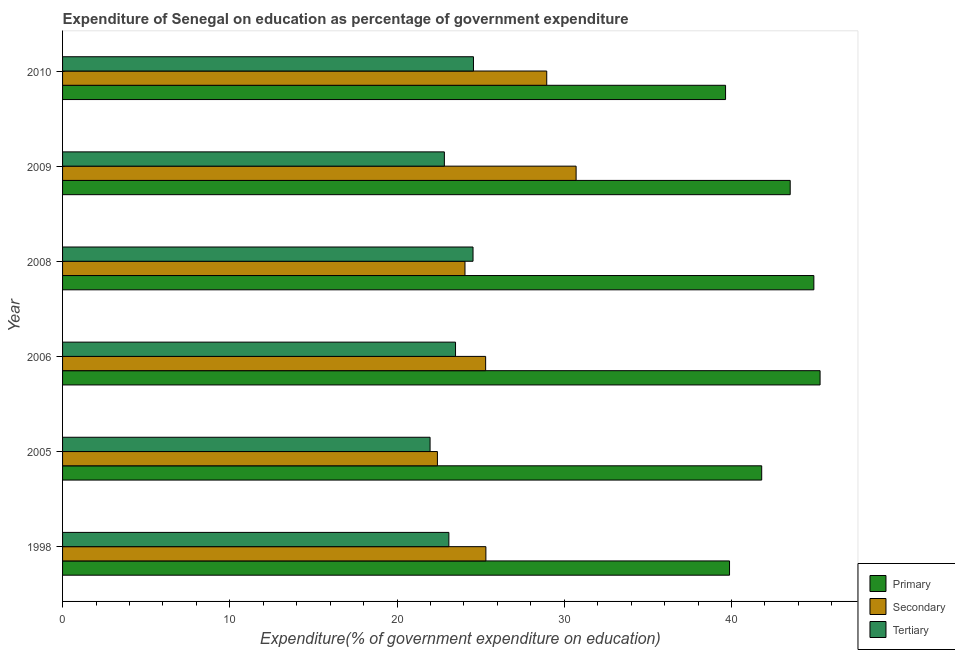How many different coloured bars are there?
Keep it short and to the point. 3. Are the number of bars per tick equal to the number of legend labels?
Your answer should be compact. Yes. How many bars are there on the 3rd tick from the bottom?
Ensure brevity in your answer.  3. What is the label of the 4th group of bars from the top?
Your response must be concise. 2006. What is the expenditure on tertiary education in 2006?
Provide a short and direct response. 23.5. Across all years, what is the maximum expenditure on tertiary education?
Offer a terse response. 24.57. Across all years, what is the minimum expenditure on primary education?
Offer a terse response. 39.65. What is the total expenditure on secondary education in the graph?
Offer a very short reply. 156.76. What is the difference between the expenditure on primary education in 2006 and that in 2008?
Offer a terse response. 0.37. What is the difference between the expenditure on tertiary education in 2009 and the expenditure on secondary education in 2010?
Keep it short and to the point. -6.12. What is the average expenditure on secondary education per year?
Your response must be concise. 26.13. In the year 2005, what is the difference between the expenditure on secondary education and expenditure on primary education?
Make the answer very short. -19.39. What is the ratio of the expenditure on secondary education in 2005 to that in 2009?
Offer a very short reply. 0.73. Is the expenditure on tertiary education in 2005 less than that in 2009?
Provide a short and direct response. Yes. What is the difference between the highest and the second highest expenditure on tertiary education?
Offer a very short reply. 0.03. What is the difference between the highest and the lowest expenditure on tertiary education?
Give a very brief answer. 2.59. What does the 2nd bar from the top in 2005 represents?
Offer a very short reply. Secondary. What does the 3rd bar from the bottom in 2010 represents?
Keep it short and to the point. Tertiary. Is it the case that in every year, the sum of the expenditure on primary education and expenditure on secondary education is greater than the expenditure on tertiary education?
Provide a succinct answer. Yes. Are all the bars in the graph horizontal?
Your answer should be compact. Yes. What is the difference between two consecutive major ticks on the X-axis?
Provide a succinct answer. 10. Does the graph contain any zero values?
Give a very brief answer. No. Does the graph contain grids?
Your answer should be very brief. No. How are the legend labels stacked?
Your answer should be very brief. Vertical. What is the title of the graph?
Your response must be concise. Expenditure of Senegal on education as percentage of government expenditure. What is the label or title of the X-axis?
Keep it short and to the point. Expenditure(% of government expenditure on education). What is the label or title of the Y-axis?
Give a very brief answer. Year. What is the Expenditure(% of government expenditure on education) of Primary in 1998?
Ensure brevity in your answer.  39.88. What is the Expenditure(% of government expenditure on education) of Secondary in 1998?
Ensure brevity in your answer.  25.32. What is the Expenditure(% of government expenditure on education) in Tertiary in 1998?
Your answer should be compact. 23.1. What is the Expenditure(% of government expenditure on education) in Primary in 2005?
Your response must be concise. 41.81. What is the Expenditure(% of government expenditure on education) of Secondary in 2005?
Give a very brief answer. 22.42. What is the Expenditure(% of government expenditure on education) in Tertiary in 2005?
Your response must be concise. 21.98. What is the Expenditure(% of government expenditure on education) in Primary in 2006?
Make the answer very short. 45.3. What is the Expenditure(% of government expenditure on education) of Secondary in 2006?
Keep it short and to the point. 25.3. What is the Expenditure(% of government expenditure on education) of Tertiary in 2006?
Give a very brief answer. 23.5. What is the Expenditure(% of government expenditure on education) in Primary in 2008?
Provide a short and direct response. 44.93. What is the Expenditure(% of government expenditure on education) in Secondary in 2008?
Ensure brevity in your answer.  24.06. What is the Expenditure(% of government expenditure on education) of Tertiary in 2008?
Give a very brief answer. 24.55. What is the Expenditure(% of government expenditure on education) in Primary in 2009?
Ensure brevity in your answer.  43.51. What is the Expenditure(% of government expenditure on education) of Secondary in 2009?
Offer a very short reply. 30.71. What is the Expenditure(% of government expenditure on education) of Tertiary in 2009?
Provide a short and direct response. 22.83. What is the Expenditure(% of government expenditure on education) in Primary in 2010?
Provide a succinct answer. 39.65. What is the Expenditure(% of government expenditure on education) of Secondary in 2010?
Make the answer very short. 28.95. What is the Expenditure(% of government expenditure on education) of Tertiary in 2010?
Ensure brevity in your answer.  24.57. Across all years, what is the maximum Expenditure(% of government expenditure on education) in Primary?
Your answer should be compact. 45.3. Across all years, what is the maximum Expenditure(% of government expenditure on education) in Secondary?
Make the answer very short. 30.71. Across all years, what is the maximum Expenditure(% of government expenditure on education) in Tertiary?
Your response must be concise. 24.57. Across all years, what is the minimum Expenditure(% of government expenditure on education) of Primary?
Make the answer very short. 39.65. Across all years, what is the minimum Expenditure(% of government expenditure on education) of Secondary?
Your response must be concise. 22.42. Across all years, what is the minimum Expenditure(% of government expenditure on education) in Tertiary?
Make the answer very short. 21.98. What is the total Expenditure(% of government expenditure on education) of Primary in the graph?
Make the answer very short. 255.08. What is the total Expenditure(% of government expenditure on education) of Secondary in the graph?
Ensure brevity in your answer.  156.76. What is the total Expenditure(% of government expenditure on education) of Tertiary in the graph?
Offer a very short reply. 140.53. What is the difference between the Expenditure(% of government expenditure on education) in Primary in 1998 and that in 2005?
Ensure brevity in your answer.  -1.92. What is the difference between the Expenditure(% of government expenditure on education) in Secondary in 1998 and that in 2005?
Provide a succinct answer. 2.9. What is the difference between the Expenditure(% of government expenditure on education) of Tertiary in 1998 and that in 2005?
Provide a short and direct response. 1.12. What is the difference between the Expenditure(% of government expenditure on education) of Primary in 1998 and that in 2006?
Give a very brief answer. -5.42. What is the difference between the Expenditure(% of government expenditure on education) of Secondary in 1998 and that in 2006?
Ensure brevity in your answer.  0.02. What is the difference between the Expenditure(% of government expenditure on education) of Tertiary in 1998 and that in 2006?
Your answer should be very brief. -0.4. What is the difference between the Expenditure(% of government expenditure on education) in Primary in 1998 and that in 2008?
Make the answer very short. -5.04. What is the difference between the Expenditure(% of government expenditure on education) in Secondary in 1998 and that in 2008?
Offer a terse response. 1.25. What is the difference between the Expenditure(% of government expenditure on education) in Tertiary in 1998 and that in 2008?
Give a very brief answer. -1.45. What is the difference between the Expenditure(% of government expenditure on education) of Primary in 1998 and that in 2009?
Offer a very short reply. -3.63. What is the difference between the Expenditure(% of government expenditure on education) in Secondary in 1998 and that in 2009?
Give a very brief answer. -5.4. What is the difference between the Expenditure(% of government expenditure on education) of Tertiary in 1998 and that in 2009?
Offer a terse response. 0.27. What is the difference between the Expenditure(% of government expenditure on education) of Primary in 1998 and that in 2010?
Ensure brevity in your answer.  0.24. What is the difference between the Expenditure(% of government expenditure on education) in Secondary in 1998 and that in 2010?
Provide a succinct answer. -3.64. What is the difference between the Expenditure(% of government expenditure on education) of Tertiary in 1998 and that in 2010?
Offer a terse response. -1.47. What is the difference between the Expenditure(% of government expenditure on education) in Primary in 2005 and that in 2006?
Offer a terse response. -3.49. What is the difference between the Expenditure(% of government expenditure on education) in Secondary in 2005 and that in 2006?
Your answer should be very brief. -2.88. What is the difference between the Expenditure(% of government expenditure on education) of Tertiary in 2005 and that in 2006?
Your answer should be compact. -1.52. What is the difference between the Expenditure(% of government expenditure on education) in Primary in 2005 and that in 2008?
Your answer should be compact. -3.12. What is the difference between the Expenditure(% of government expenditure on education) in Secondary in 2005 and that in 2008?
Offer a terse response. -1.65. What is the difference between the Expenditure(% of government expenditure on education) in Tertiary in 2005 and that in 2008?
Your response must be concise. -2.57. What is the difference between the Expenditure(% of government expenditure on education) in Primary in 2005 and that in 2009?
Your response must be concise. -1.7. What is the difference between the Expenditure(% of government expenditure on education) in Secondary in 2005 and that in 2009?
Offer a very short reply. -8.29. What is the difference between the Expenditure(% of government expenditure on education) of Tertiary in 2005 and that in 2009?
Provide a short and direct response. -0.85. What is the difference between the Expenditure(% of government expenditure on education) in Primary in 2005 and that in 2010?
Provide a succinct answer. 2.16. What is the difference between the Expenditure(% of government expenditure on education) of Secondary in 2005 and that in 2010?
Provide a succinct answer. -6.54. What is the difference between the Expenditure(% of government expenditure on education) of Tertiary in 2005 and that in 2010?
Keep it short and to the point. -2.59. What is the difference between the Expenditure(% of government expenditure on education) in Primary in 2006 and that in 2008?
Provide a short and direct response. 0.37. What is the difference between the Expenditure(% of government expenditure on education) of Secondary in 2006 and that in 2008?
Provide a short and direct response. 1.24. What is the difference between the Expenditure(% of government expenditure on education) of Tertiary in 2006 and that in 2008?
Give a very brief answer. -1.05. What is the difference between the Expenditure(% of government expenditure on education) of Primary in 2006 and that in 2009?
Your answer should be very brief. 1.79. What is the difference between the Expenditure(% of government expenditure on education) of Secondary in 2006 and that in 2009?
Your answer should be compact. -5.41. What is the difference between the Expenditure(% of government expenditure on education) in Tertiary in 2006 and that in 2009?
Keep it short and to the point. 0.67. What is the difference between the Expenditure(% of government expenditure on education) in Primary in 2006 and that in 2010?
Ensure brevity in your answer.  5.65. What is the difference between the Expenditure(% of government expenditure on education) of Secondary in 2006 and that in 2010?
Offer a very short reply. -3.65. What is the difference between the Expenditure(% of government expenditure on education) of Tertiary in 2006 and that in 2010?
Make the answer very short. -1.07. What is the difference between the Expenditure(% of government expenditure on education) in Primary in 2008 and that in 2009?
Make the answer very short. 1.41. What is the difference between the Expenditure(% of government expenditure on education) in Secondary in 2008 and that in 2009?
Provide a short and direct response. -6.65. What is the difference between the Expenditure(% of government expenditure on education) of Tertiary in 2008 and that in 2009?
Provide a succinct answer. 1.71. What is the difference between the Expenditure(% of government expenditure on education) in Primary in 2008 and that in 2010?
Ensure brevity in your answer.  5.28. What is the difference between the Expenditure(% of government expenditure on education) in Secondary in 2008 and that in 2010?
Offer a very short reply. -4.89. What is the difference between the Expenditure(% of government expenditure on education) in Tertiary in 2008 and that in 2010?
Offer a very short reply. -0.03. What is the difference between the Expenditure(% of government expenditure on education) of Primary in 2009 and that in 2010?
Provide a succinct answer. 3.87. What is the difference between the Expenditure(% of government expenditure on education) in Secondary in 2009 and that in 2010?
Your answer should be compact. 1.76. What is the difference between the Expenditure(% of government expenditure on education) in Tertiary in 2009 and that in 2010?
Provide a short and direct response. -1.74. What is the difference between the Expenditure(% of government expenditure on education) in Primary in 1998 and the Expenditure(% of government expenditure on education) in Secondary in 2005?
Keep it short and to the point. 17.47. What is the difference between the Expenditure(% of government expenditure on education) in Primary in 1998 and the Expenditure(% of government expenditure on education) in Tertiary in 2005?
Ensure brevity in your answer.  17.91. What is the difference between the Expenditure(% of government expenditure on education) in Secondary in 1998 and the Expenditure(% of government expenditure on education) in Tertiary in 2005?
Keep it short and to the point. 3.34. What is the difference between the Expenditure(% of government expenditure on education) of Primary in 1998 and the Expenditure(% of government expenditure on education) of Secondary in 2006?
Offer a very short reply. 14.58. What is the difference between the Expenditure(% of government expenditure on education) of Primary in 1998 and the Expenditure(% of government expenditure on education) of Tertiary in 2006?
Your answer should be compact. 16.38. What is the difference between the Expenditure(% of government expenditure on education) of Secondary in 1998 and the Expenditure(% of government expenditure on education) of Tertiary in 2006?
Ensure brevity in your answer.  1.82. What is the difference between the Expenditure(% of government expenditure on education) in Primary in 1998 and the Expenditure(% of government expenditure on education) in Secondary in 2008?
Your response must be concise. 15.82. What is the difference between the Expenditure(% of government expenditure on education) of Primary in 1998 and the Expenditure(% of government expenditure on education) of Tertiary in 2008?
Give a very brief answer. 15.34. What is the difference between the Expenditure(% of government expenditure on education) in Secondary in 1998 and the Expenditure(% of government expenditure on education) in Tertiary in 2008?
Give a very brief answer. 0.77. What is the difference between the Expenditure(% of government expenditure on education) in Primary in 1998 and the Expenditure(% of government expenditure on education) in Secondary in 2009?
Offer a very short reply. 9.17. What is the difference between the Expenditure(% of government expenditure on education) in Primary in 1998 and the Expenditure(% of government expenditure on education) in Tertiary in 2009?
Your answer should be compact. 17.05. What is the difference between the Expenditure(% of government expenditure on education) of Secondary in 1998 and the Expenditure(% of government expenditure on education) of Tertiary in 2009?
Ensure brevity in your answer.  2.48. What is the difference between the Expenditure(% of government expenditure on education) of Primary in 1998 and the Expenditure(% of government expenditure on education) of Secondary in 2010?
Provide a succinct answer. 10.93. What is the difference between the Expenditure(% of government expenditure on education) in Primary in 1998 and the Expenditure(% of government expenditure on education) in Tertiary in 2010?
Give a very brief answer. 15.31. What is the difference between the Expenditure(% of government expenditure on education) in Secondary in 1998 and the Expenditure(% of government expenditure on education) in Tertiary in 2010?
Give a very brief answer. 0.74. What is the difference between the Expenditure(% of government expenditure on education) in Primary in 2005 and the Expenditure(% of government expenditure on education) in Secondary in 2006?
Give a very brief answer. 16.51. What is the difference between the Expenditure(% of government expenditure on education) in Primary in 2005 and the Expenditure(% of government expenditure on education) in Tertiary in 2006?
Ensure brevity in your answer.  18.31. What is the difference between the Expenditure(% of government expenditure on education) of Secondary in 2005 and the Expenditure(% of government expenditure on education) of Tertiary in 2006?
Offer a terse response. -1.08. What is the difference between the Expenditure(% of government expenditure on education) in Primary in 2005 and the Expenditure(% of government expenditure on education) in Secondary in 2008?
Your response must be concise. 17.74. What is the difference between the Expenditure(% of government expenditure on education) in Primary in 2005 and the Expenditure(% of government expenditure on education) in Tertiary in 2008?
Ensure brevity in your answer.  17.26. What is the difference between the Expenditure(% of government expenditure on education) of Secondary in 2005 and the Expenditure(% of government expenditure on education) of Tertiary in 2008?
Offer a terse response. -2.13. What is the difference between the Expenditure(% of government expenditure on education) in Primary in 2005 and the Expenditure(% of government expenditure on education) in Secondary in 2009?
Your answer should be very brief. 11.1. What is the difference between the Expenditure(% of government expenditure on education) in Primary in 2005 and the Expenditure(% of government expenditure on education) in Tertiary in 2009?
Provide a short and direct response. 18.98. What is the difference between the Expenditure(% of government expenditure on education) in Secondary in 2005 and the Expenditure(% of government expenditure on education) in Tertiary in 2009?
Your answer should be very brief. -0.42. What is the difference between the Expenditure(% of government expenditure on education) of Primary in 2005 and the Expenditure(% of government expenditure on education) of Secondary in 2010?
Your answer should be very brief. 12.86. What is the difference between the Expenditure(% of government expenditure on education) of Primary in 2005 and the Expenditure(% of government expenditure on education) of Tertiary in 2010?
Provide a succinct answer. 17.24. What is the difference between the Expenditure(% of government expenditure on education) in Secondary in 2005 and the Expenditure(% of government expenditure on education) in Tertiary in 2010?
Provide a succinct answer. -2.16. What is the difference between the Expenditure(% of government expenditure on education) in Primary in 2006 and the Expenditure(% of government expenditure on education) in Secondary in 2008?
Your response must be concise. 21.24. What is the difference between the Expenditure(% of government expenditure on education) in Primary in 2006 and the Expenditure(% of government expenditure on education) in Tertiary in 2008?
Keep it short and to the point. 20.75. What is the difference between the Expenditure(% of government expenditure on education) in Secondary in 2006 and the Expenditure(% of government expenditure on education) in Tertiary in 2008?
Your answer should be very brief. 0.75. What is the difference between the Expenditure(% of government expenditure on education) of Primary in 2006 and the Expenditure(% of government expenditure on education) of Secondary in 2009?
Ensure brevity in your answer.  14.59. What is the difference between the Expenditure(% of government expenditure on education) of Primary in 2006 and the Expenditure(% of government expenditure on education) of Tertiary in 2009?
Provide a short and direct response. 22.47. What is the difference between the Expenditure(% of government expenditure on education) in Secondary in 2006 and the Expenditure(% of government expenditure on education) in Tertiary in 2009?
Make the answer very short. 2.47. What is the difference between the Expenditure(% of government expenditure on education) of Primary in 2006 and the Expenditure(% of government expenditure on education) of Secondary in 2010?
Your answer should be very brief. 16.35. What is the difference between the Expenditure(% of government expenditure on education) in Primary in 2006 and the Expenditure(% of government expenditure on education) in Tertiary in 2010?
Your answer should be very brief. 20.73. What is the difference between the Expenditure(% of government expenditure on education) in Secondary in 2006 and the Expenditure(% of government expenditure on education) in Tertiary in 2010?
Offer a very short reply. 0.73. What is the difference between the Expenditure(% of government expenditure on education) in Primary in 2008 and the Expenditure(% of government expenditure on education) in Secondary in 2009?
Ensure brevity in your answer.  14.22. What is the difference between the Expenditure(% of government expenditure on education) in Primary in 2008 and the Expenditure(% of government expenditure on education) in Tertiary in 2009?
Provide a succinct answer. 22.1. What is the difference between the Expenditure(% of government expenditure on education) in Secondary in 2008 and the Expenditure(% of government expenditure on education) in Tertiary in 2009?
Offer a terse response. 1.23. What is the difference between the Expenditure(% of government expenditure on education) of Primary in 2008 and the Expenditure(% of government expenditure on education) of Secondary in 2010?
Provide a short and direct response. 15.97. What is the difference between the Expenditure(% of government expenditure on education) of Primary in 2008 and the Expenditure(% of government expenditure on education) of Tertiary in 2010?
Your answer should be very brief. 20.36. What is the difference between the Expenditure(% of government expenditure on education) of Secondary in 2008 and the Expenditure(% of government expenditure on education) of Tertiary in 2010?
Your response must be concise. -0.51. What is the difference between the Expenditure(% of government expenditure on education) in Primary in 2009 and the Expenditure(% of government expenditure on education) in Secondary in 2010?
Offer a terse response. 14.56. What is the difference between the Expenditure(% of government expenditure on education) in Primary in 2009 and the Expenditure(% of government expenditure on education) in Tertiary in 2010?
Your answer should be compact. 18.94. What is the difference between the Expenditure(% of government expenditure on education) in Secondary in 2009 and the Expenditure(% of government expenditure on education) in Tertiary in 2010?
Make the answer very short. 6.14. What is the average Expenditure(% of government expenditure on education) in Primary per year?
Make the answer very short. 42.51. What is the average Expenditure(% of government expenditure on education) in Secondary per year?
Your answer should be compact. 26.13. What is the average Expenditure(% of government expenditure on education) in Tertiary per year?
Ensure brevity in your answer.  23.42. In the year 1998, what is the difference between the Expenditure(% of government expenditure on education) of Primary and Expenditure(% of government expenditure on education) of Secondary?
Keep it short and to the point. 14.57. In the year 1998, what is the difference between the Expenditure(% of government expenditure on education) in Primary and Expenditure(% of government expenditure on education) in Tertiary?
Provide a short and direct response. 16.78. In the year 1998, what is the difference between the Expenditure(% of government expenditure on education) of Secondary and Expenditure(% of government expenditure on education) of Tertiary?
Make the answer very short. 2.21. In the year 2005, what is the difference between the Expenditure(% of government expenditure on education) of Primary and Expenditure(% of government expenditure on education) of Secondary?
Provide a short and direct response. 19.39. In the year 2005, what is the difference between the Expenditure(% of government expenditure on education) of Primary and Expenditure(% of government expenditure on education) of Tertiary?
Provide a succinct answer. 19.83. In the year 2005, what is the difference between the Expenditure(% of government expenditure on education) in Secondary and Expenditure(% of government expenditure on education) in Tertiary?
Keep it short and to the point. 0.44. In the year 2006, what is the difference between the Expenditure(% of government expenditure on education) in Primary and Expenditure(% of government expenditure on education) in Secondary?
Offer a very short reply. 20. In the year 2006, what is the difference between the Expenditure(% of government expenditure on education) of Primary and Expenditure(% of government expenditure on education) of Tertiary?
Provide a short and direct response. 21.8. In the year 2006, what is the difference between the Expenditure(% of government expenditure on education) in Secondary and Expenditure(% of government expenditure on education) in Tertiary?
Keep it short and to the point. 1.8. In the year 2008, what is the difference between the Expenditure(% of government expenditure on education) in Primary and Expenditure(% of government expenditure on education) in Secondary?
Ensure brevity in your answer.  20.86. In the year 2008, what is the difference between the Expenditure(% of government expenditure on education) of Primary and Expenditure(% of government expenditure on education) of Tertiary?
Your answer should be compact. 20.38. In the year 2008, what is the difference between the Expenditure(% of government expenditure on education) of Secondary and Expenditure(% of government expenditure on education) of Tertiary?
Your answer should be very brief. -0.48. In the year 2009, what is the difference between the Expenditure(% of government expenditure on education) of Primary and Expenditure(% of government expenditure on education) of Secondary?
Ensure brevity in your answer.  12.8. In the year 2009, what is the difference between the Expenditure(% of government expenditure on education) of Primary and Expenditure(% of government expenditure on education) of Tertiary?
Your response must be concise. 20.68. In the year 2009, what is the difference between the Expenditure(% of government expenditure on education) of Secondary and Expenditure(% of government expenditure on education) of Tertiary?
Offer a terse response. 7.88. In the year 2010, what is the difference between the Expenditure(% of government expenditure on education) of Primary and Expenditure(% of government expenditure on education) of Secondary?
Ensure brevity in your answer.  10.69. In the year 2010, what is the difference between the Expenditure(% of government expenditure on education) in Primary and Expenditure(% of government expenditure on education) in Tertiary?
Give a very brief answer. 15.08. In the year 2010, what is the difference between the Expenditure(% of government expenditure on education) of Secondary and Expenditure(% of government expenditure on education) of Tertiary?
Provide a succinct answer. 4.38. What is the ratio of the Expenditure(% of government expenditure on education) in Primary in 1998 to that in 2005?
Give a very brief answer. 0.95. What is the ratio of the Expenditure(% of government expenditure on education) of Secondary in 1998 to that in 2005?
Make the answer very short. 1.13. What is the ratio of the Expenditure(% of government expenditure on education) of Tertiary in 1998 to that in 2005?
Your answer should be very brief. 1.05. What is the ratio of the Expenditure(% of government expenditure on education) in Primary in 1998 to that in 2006?
Provide a succinct answer. 0.88. What is the ratio of the Expenditure(% of government expenditure on education) of Secondary in 1998 to that in 2006?
Make the answer very short. 1. What is the ratio of the Expenditure(% of government expenditure on education) in Primary in 1998 to that in 2008?
Your response must be concise. 0.89. What is the ratio of the Expenditure(% of government expenditure on education) of Secondary in 1998 to that in 2008?
Make the answer very short. 1.05. What is the ratio of the Expenditure(% of government expenditure on education) in Tertiary in 1998 to that in 2008?
Provide a succinct answer. 0.94. What is the ratio of the Expenditure(% of government expenditure on education) of Primary in 1998 to that in 2009?
Offer a terse response. 0.92. What is the ratio of the Expenditure(% of government expenditure on education) of Secondary in 1998 to that in 2009?
Offer a terse response. 0.82. What is the ratio of the Expenditure(% of government expenditure on education) in Tertiary in 1998 to that in 2009?
Make the answer very short. 1.01. What is the ratio of the Expenditure(% of government expenditure on education) of Primary in 1998 to that in 2010?
Your answer should be compact. 1.01. What is the ratio of the Expenditure(% of government expenditure on education) in Secondary in 1998 to that in 2010?
Your answer should be compact. 0.87. What is the ratio of the Expenditure(% of government expenditure on education) in Tertiary in 1998 to that in 2010?
Make the answer very short. 0.94. What is the ratio of the Expenditure(% of government expenditure on education) in Primary in 2005 to that in 2006?
Your response must be concise. 0.92. What is the ratio of the Expenditure(% of government expenditure on education) of Secondary in 2005 to that in 2006?
Ensure brevity in your answer.  0.89. What is the ratio of the Expenditure(% of government expenditure on education) of Tertiary in 2005 to that in 2006?
Give a very brief answer. 0.94. What is the ratio of the Expenditure(% of government expenditure on education) of Primary in 2005 to that in 2008?
Make the answer very short. 0.93. What is the ratio of the Expenditure(% of government expenditure on education) in Secondary in 2005 to that in 2008?
Give a very brief answer. 0.93. What is the ratio of the Expenditure(% of government expenditure on education) in Tertiary in 2005 to that in 2008?
Keep it short and to the point. 0.9. What is the ratio of the Expenditure(% of government expenditure on education) of Primary in 2005 to that in 2009?
Your answer should be very brief. 0.96. What is the ratio of the Expenditure(% of government expenditure on education) of Secondary in 2005 to that in 2009?
Offer a terse response. 0.73. What is the ratio of the Expenditure(% of government expenditure on education) in Tertiary in 2005 to that in 2009?
Provide a short and direct response. 0.96. What is the ratio of the Expenditure(% of government expenditure on education) of Primary in 2005 to that in 2010?
Keep it short and to the point. 1.05. What is the ratio of the Expenditure(% of government expenditure on education) of Secondary in 2005 to that in 2010?
Keep it short and to the point. 0.77. What is the ratio of the Expenditure(% of government expenditure on education) in Tertiary in 2005 to that in 2010?
Keep it short and to the point. 0.89. What is the ratio of the Expenditure(% of government expenditure on education) of Primary in 2006 to that in 2008?
Offer a terse response. 1.01. What is the ratio of the Expenditure(% of government expenditure on education) of Secondary in 2006 to that in 2008?
Offer a terse response. 1.05. What is the ratio of the Expenditure(% of government expenditure on education) of Tertiary in 2006 to that in 2008?
Give a very brief answer. 0.96. What is the ratio of the Expenditure(% of government expenditure on education) in Primary in 2006 to that in 2009?
Offer a terse response. 1.04. What is the ratio of the Expenditure(% of government expenditure on education) in Secondary in 2006 to that in 2009?
Make the answer very short. 0.82. What is the ratio of the Expenditure(% of government expenditure on education) in Tertiary in 2006 to that in 2009?
Keep it short and to the point. 1.03. What is the ratio of the Expenditure(% of government expenditure on education) of Primary in 2006 to that in 2010?
Keep it short and to the point. 1.14. What is the ratio of the Expenditure(% of government expenditure on education) of Secondary in 2006 to that in 2010?
Make the answer very short. 0.87. What is the ratio of the Expenditure(% of government expenditure on education) of Tertiary in 2006 to that in 2010?
Ensure brevity in your answer.  0.96. What is the ratio of the Expenditure(% of government expenditure on education) in Primary in 2008 to that in 2009?
Keep it short and to the point. 1.03. What is the ratio of the Expenditure(% of government expenditure on education) of Secondary in 2008 to that in 2009?
Your response must be concise. 0.78. What is the ratio of the Expenditure(% of government expenditure on education) in Tertiary in 2008 to that in 2009?
Provide a succinct answer. 1.08. What is the ratio of the Expenditure(% of government expenditure on education) of Primary in 2008 to that in 2010?
Keep it short and to the point. 1.13. What is the ratio of the Expenditure(% of government expenditure on education) in Secondary in 2008 to that in 2010?
Ensure brevity in your answer.  0.83. What is the ratio of the Expenditure(% of government expenditure on education) in Tertiary in 2008 to that in 2010?
Keep it short and to the point. 1. What is the ratio of the Expenditure(% of government expenditure on education) in Primary in 2009 to that in 2010?
Your answer should be very brief. 1.1. What is the ratio of the Expenditure(% of government expenditure on education) in Secondary in 2009 to that in 2010?
Your answer should be very brief. 1.06. What is the ratio of the Expenditure(% of government expenditure on education) in Tertiary in 2009 to that in 2010?
Your response must be concise. 0.93. What is the difference between the highest and the second highest Expenditure(% of government expenditure on education) in Primary?
Give a very brief answer. 0.37. What is the difference between the highest and the second highest Expenditure(% of government expenditure on education) in Secondary?
Your answer should be compact. 1.76. What is the difference between the highest and the second highest Expenditure(% of government expenditure on education) in Tertiary?
Your answer should be very brief. 0.03. What is the difference between the highest and the lowest Expenditure(% of government expenditure on education) in Primary?
Provide a succinct answer. 5.65. What is the difference between the highest and the lowest Expenditure(% of government expenditure on education) of Secondary?
Provide a succinct answer. 8.29. What is the difference between the highest and the lowest Expenditure(% of government expenditure on education) in Tertiary?
Give a very brief answer. 2.59. 